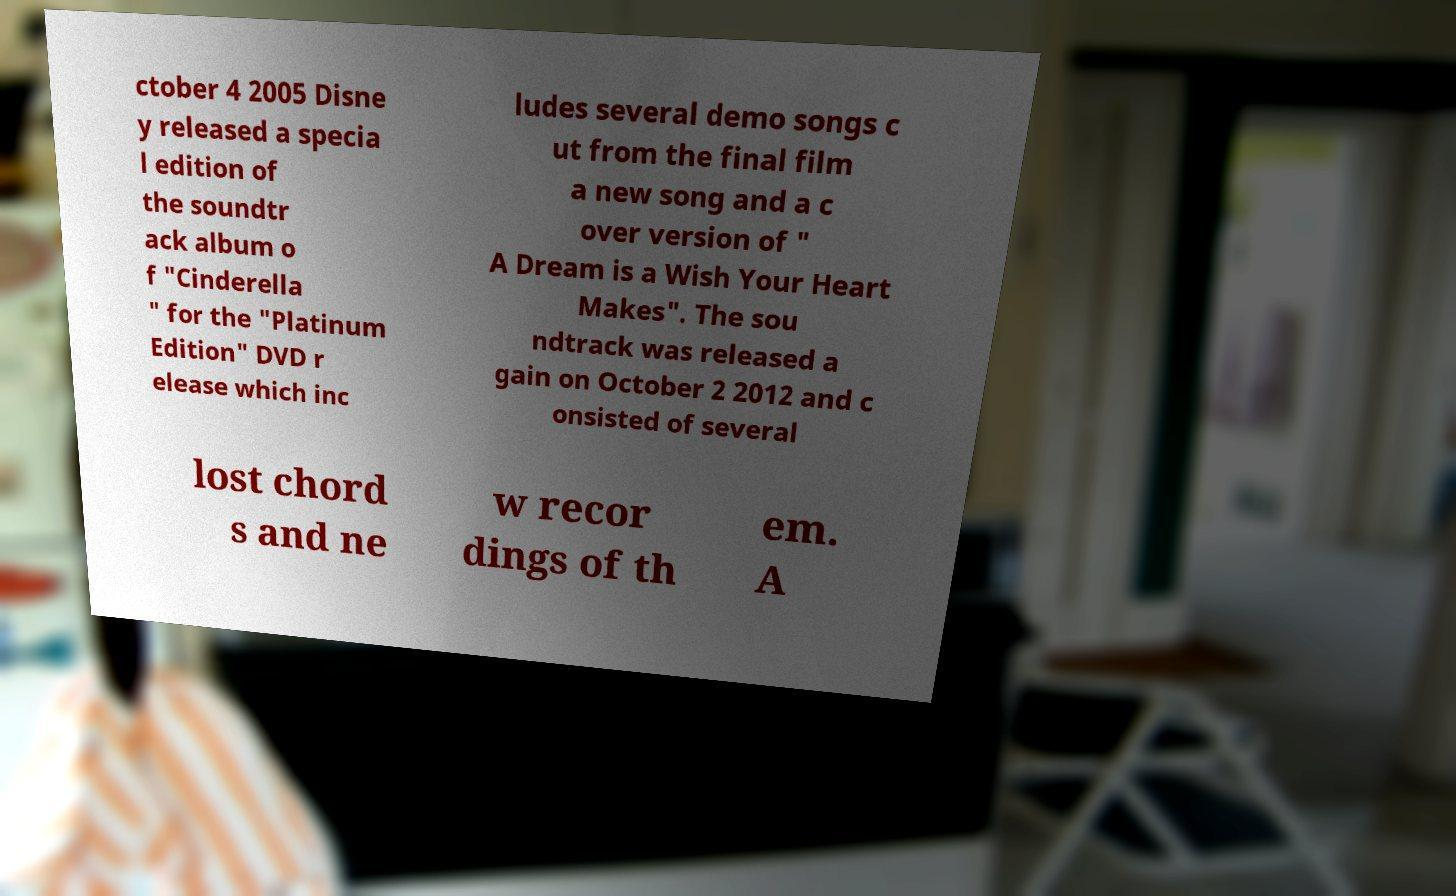What messages or text are displayed in this image? I need them in a readable, typed format. ctober 4 2005 Disne y released a specia l edition of the soundtr ack album o f "Cinderella " for the "Platinum Edition" DVD r elease which inc ludes several demo songs c ut from the final film a new song and a c over version of " A Dream is a Wish Your Heart Makes". The sou ndtrack was released a gain on October 2 2012 and c onsisted of several lost chord s and ne w recor dings of th em. A 